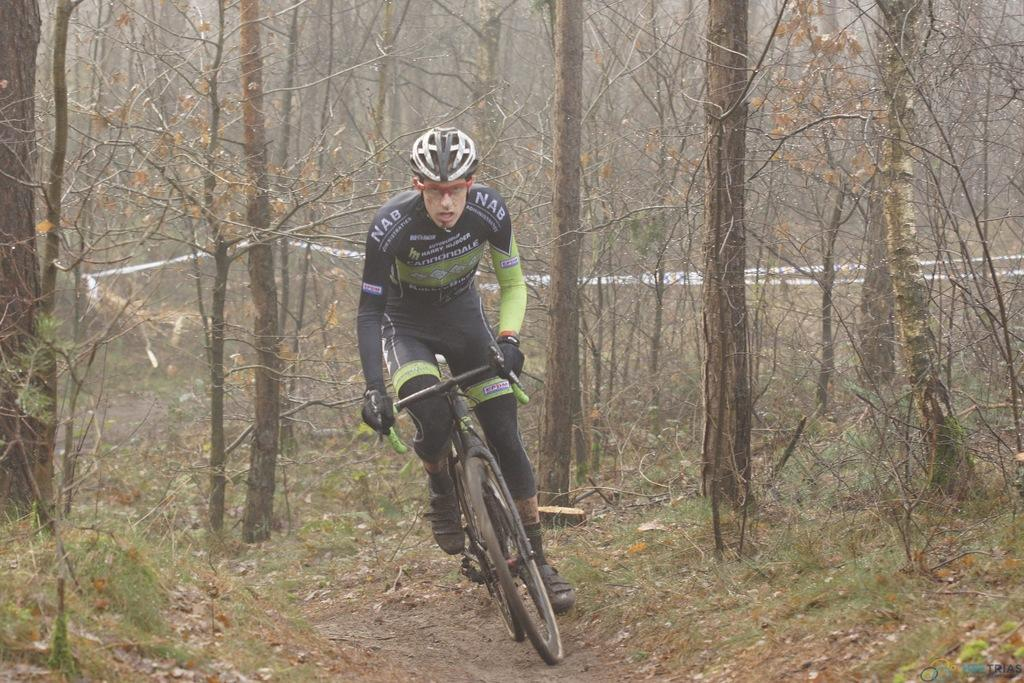What is the main subject of the image? There is a person in the image. What is the person doing in the image? The person is riding a bicycle. Can you describe the person's clothing in the image? The person is wearing a black and green color dress. What can be seen in the background of the image? There are dried trees in the background of the image. What type of button can be seen on the person's dress in the image? There is no button visible on the person's dress in the image. What kind of plant is growing near the dried trees in the image? There is no plant growing near the dried trees in the image; only the trees are visible in the background. 